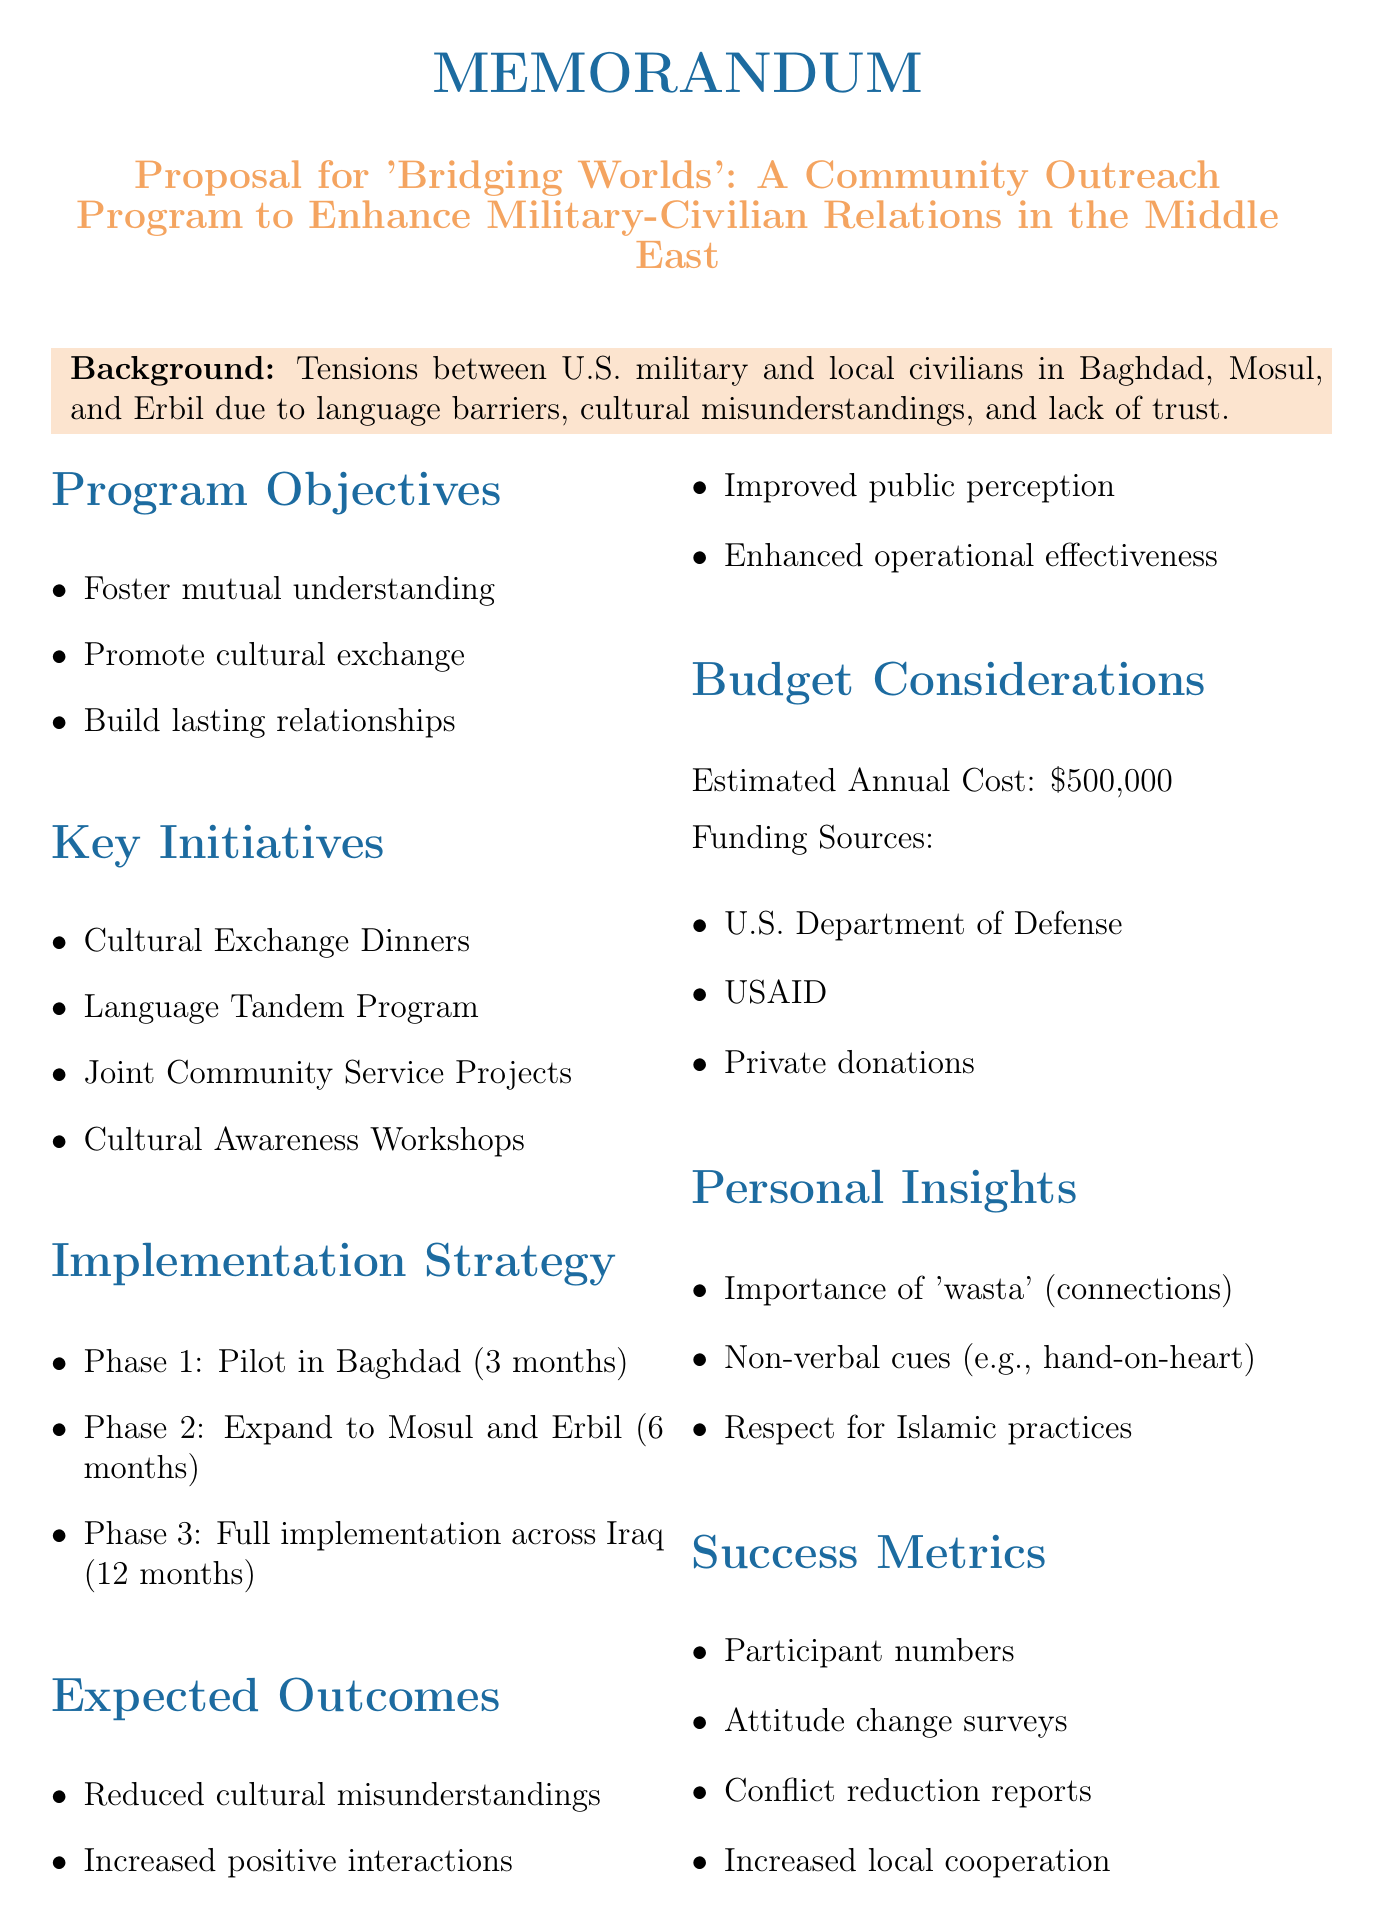What is the title of the proposal? The title is mentioned at the beginning of the memo and emphasizes the purpose of the document.
Answer: Proposal for 'Bridging Worlds': A Community Outreach Program to Enhance Military-Civilian Relations in the Middle East What are the identified issues? The document lists specific challenges contributing to tensions between military and civilians.
Answer: Language barriers, Cultural misunderstandings, Lack of trust and communication How many phases are in the implementation strategy? The implementation strategy is divided into three distinct phases.
Answer: 3 Where will the Cultural Exchange Dinners be held? The document specifies the location for the monthly gatherings aimed at fostering relationships.
Answer: Al-Rasheed Hotel, Baghdad What is the estimated annual cost of the program? The document clearly states the financial consideration for the program.
Answer: $500,000 Who are key stakeholders mentioned in the memo? The key stakeholders are important entities involved in the program's execution as listed in the document.
Answer: U.S. Central Command (CENTCOM), Iraqi Ministry of Defense, Local municipal governments, NGOs like Mercy Corps and International Rescue Committee What is one reason for increased operational effectiveness? The expected outcomes include elements that contribute to operational efficiency based on improved understanding.
Answer: Improved public perception of U.S. military presence What cultural element is incorporated in the Cultural Exchange Dinners? The document highlights a tradition that will be part of the cultural exchange initiative.
Answer: Incorporation of Iraqi hospitality traditions like 'gahwa' (coffee ceremony) 